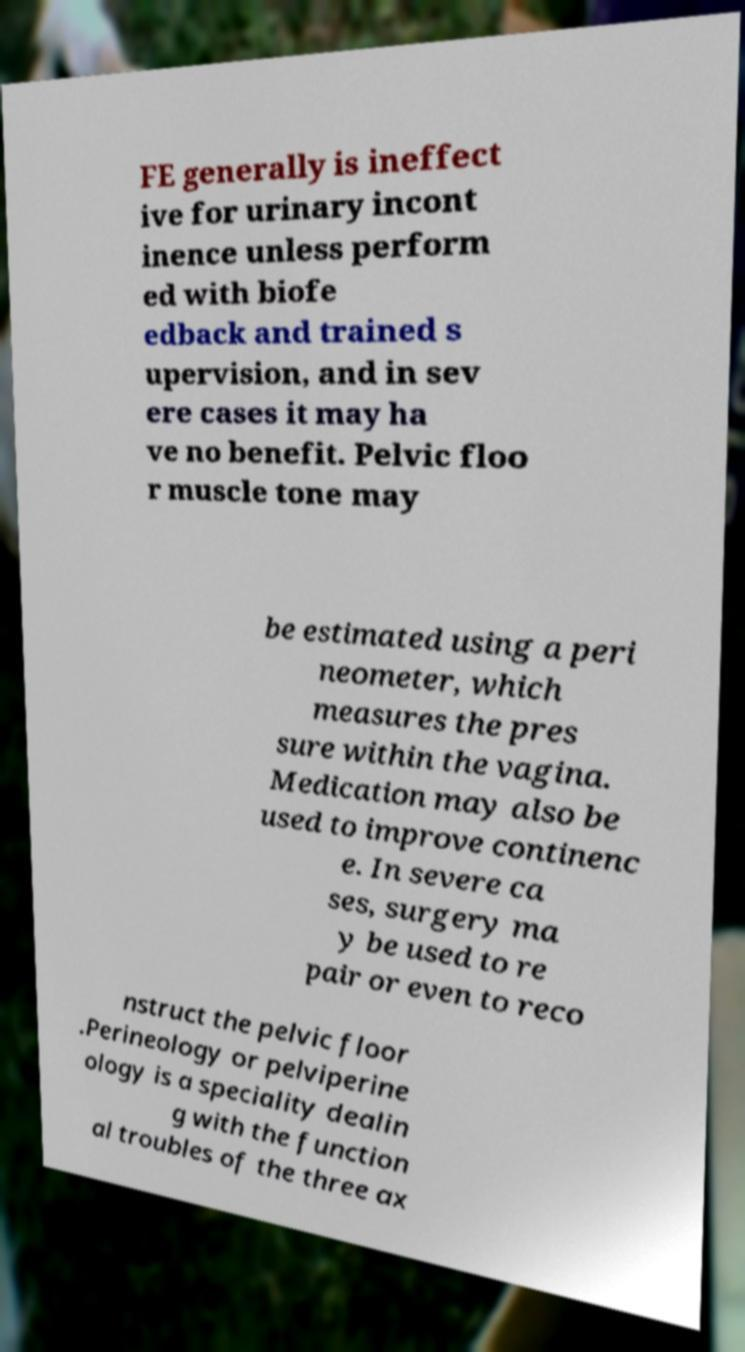I need the written content from this picture converted into text. Can you do that? FE generally is ineffect ive for urinary incont inence unless perform ed with biofe edback and trained s upervision, and in sev ere cases it may ha ve no benefit. Pelvic floo r muscle tone may be estimated using a peri neometer, which measures the pres sure within the vagina. Medication may also be used to improve continenc e. In severe ca ses, surgery ma y be used to re pair or even to reco nstruct the pelvic floor .Perineology or pelviperine ology is a speciality dealin g with the function al troubles of the three ax 